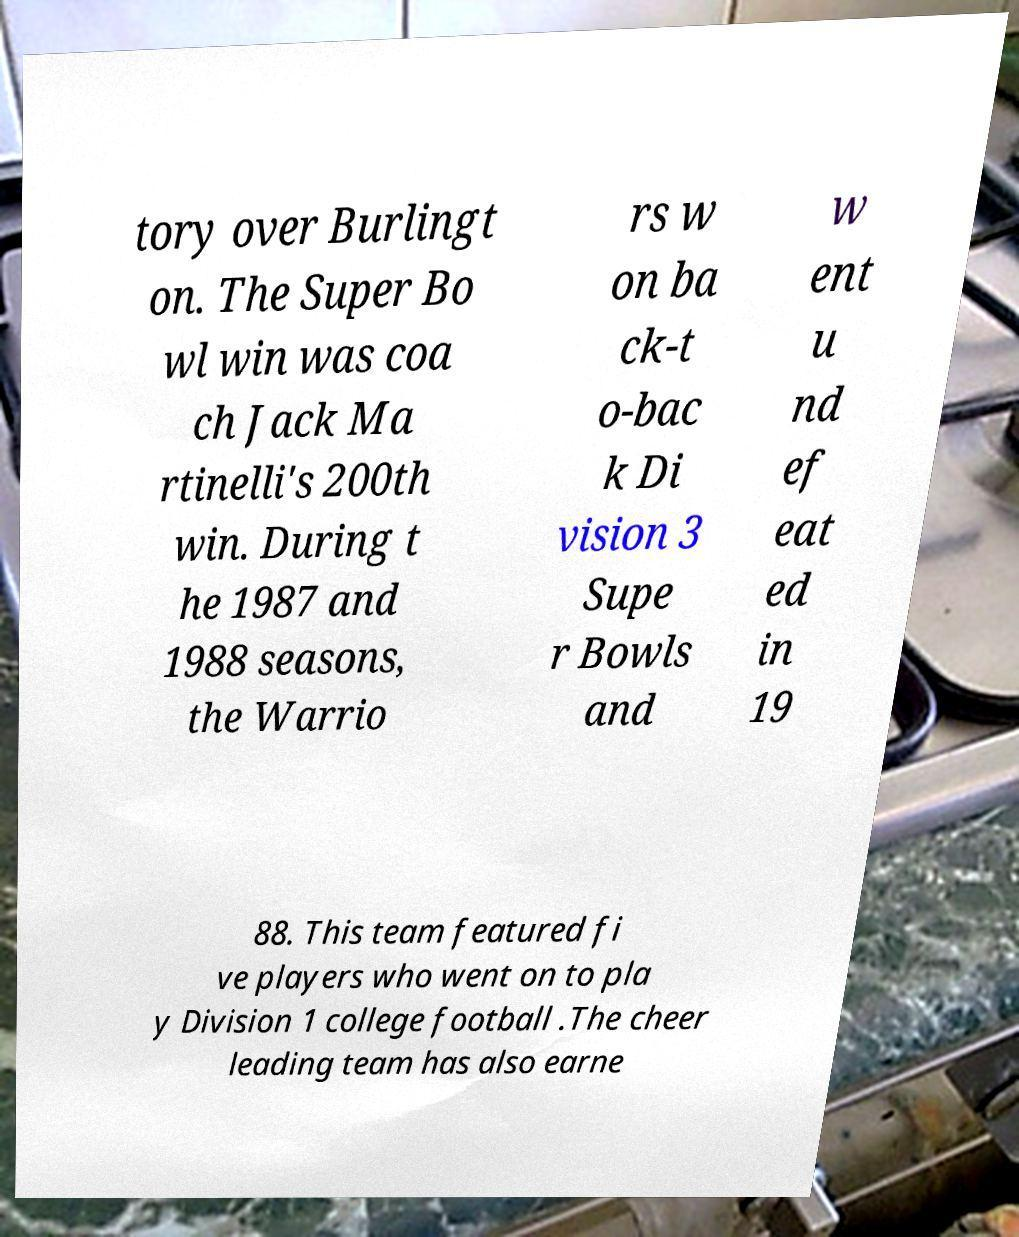There's text embedded in this image that I need extracted. Can you transcribe it verbatim? tory over Burlingt on. The Super Bo wl win was coa ch Jack Ma rtinelli's 200th win. During t he 1987 and 1988 seasons, the Warrio rs w on ba ck-t o-bac k Di vision 3 Supe r Bowls and w ent u nd ef eat ed in 19 88. This team featured fi ve players who went on to pla y Division 1 college football .The cheer leading team has also earne 